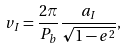<formula> <loc_0><loc_0><loc_500><loc_500>v _ { I } = \frac { 2 \pi } { P _ { b } } \frac { a _ { I } } { \sqrt { 1 - e ^ { 2 } } } ,</formula> 